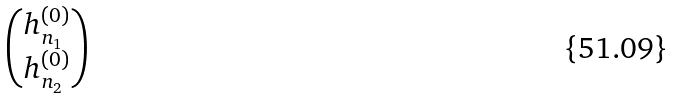Convert formula to latex. <formula><loc_0><loc_0><loc_500><loc_500>\begin{pmatrix} h _ { n _ { 1 } } ^ { ( 0 ) } \\ h _ { n _ { 2 } } ^ { ( 0 ) } \end{pmatrix}</formula> 